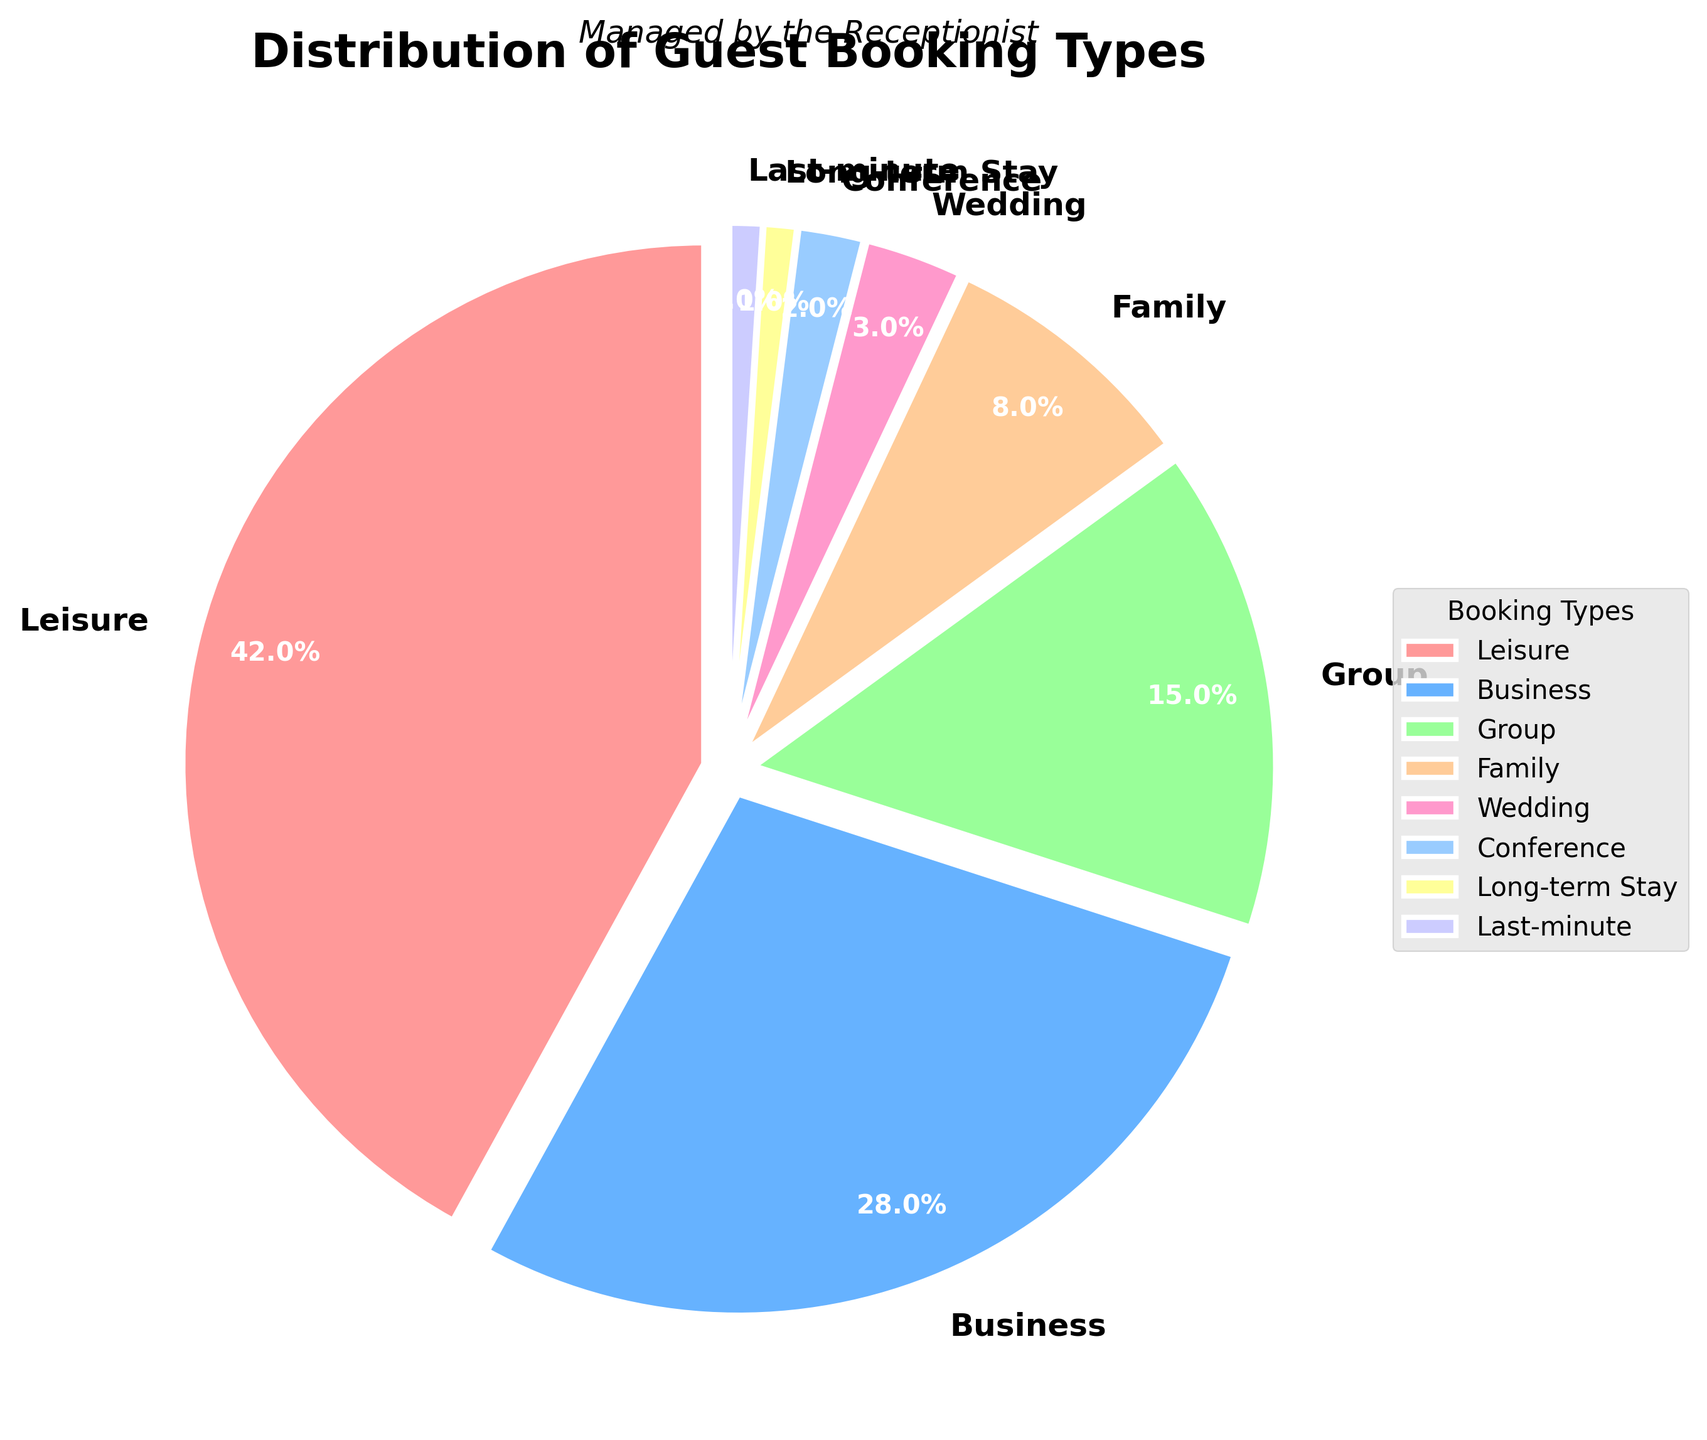Which booking type has the highest percentage? The largest section of the pie chart represents the booking type with the highest percentage. Refer to the section with the biggest area and its corresponding label, which is Leisure with 42%.
Answer: Leisure What is the total percentage of Business and Group bookings combined? To find the combined percentage of Business and Group bookings, add the percentages for Business (28%) and Group (15%). 28 + 15 equals 43.
Answer: 43% Which booking type has the smallest percentage? The smallest section of the pie chart represents the booking type with the smallest percentage. Refer to the section with the smallest area and its corresponding label, which is Long-term Stay and Last-minute each with 1%.
Answer: Long-term Stay and Last-minute How many more percent is Leisure compared to Business bookings? To find out how much more Leisure bookings are compared to Business, subtract the percentage of Business bookings (28%) from Leisure bookings (42%). 42 - 28 equals 14.
Answer: 14% What is the combined percentage of Family, Wedding, and Conference bookings? To find the combined percentage of Family, Wedding, and Conference bookings, add their percentages: Family (8%), Wedding (3%), and Conference (2%). 8 + 3 + 2 equals 13.
Answer: 13% Which booking types are represented by shades of blue? Identify sections of the pie chart that are colored in shades of blue and read their corresponding labels. These are Business and Conference bookings.
Answer: Business and Conference How does the percentage of Group bookings compare to Family bookings? Compare the size of the pie chart sections for Group bookings (15%) and Family bookings (8%). Group bookings are larger with 15%.
Answer: Group bookings are 7% more What percentage of bookings are not for Leisure? Sum all the percentages excluding Leisure (42%). The remaining categories are Business (28%), Group (15%), Family (8%), Wedding (3%), Conference (2%), Long-term Stay (1%), and Last-minute (1%). 28 + 15 + 8 + 3 + 2 + 1 + 1 equals 58.
Answer: 58% Which two categories combined make up less than 5% of total bookings? Identify two categories that together total less than 5%. Wedding (3%) and each of Long-term Stay and Last-minute (1% each) combined make up 3 + 1 + 1 = 5%, which is exactly 5%, so find Conference (2%) and each of Long-term Stay and Last-minute (1% each) together make up 4%.
Answer: Conference and Long-term Stay or Last-minute 